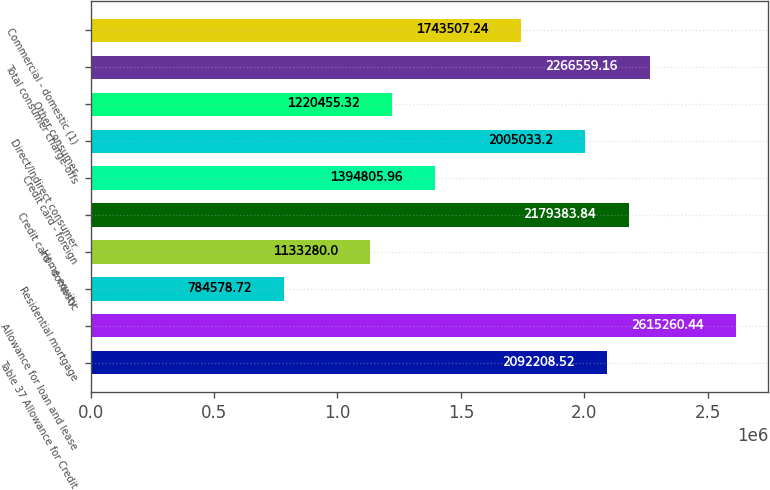Convert chart to OTSL. <chart><loc_0><loc_0><loc_500><loc_500><bar_chart><fcel>Table 37 Allowance for Credit<fcel>Allowance for loan and lease<fcel>Residential mortgage<fcel>Home equity<fcel>Credit card - domestic<fcel>Credit card - foreign<fcel>Direct/Indirect consumer<fcel>Other consumer<fcel>Total consumer charge-offs<fcel>Commercial - domestic (1)<nl><fcel>2.09221e+06<fcel>2.61526e+06<fcel>784579<fcel>1.13328e+06<fcel>2.17938e+06<fcel>1.39481e+06<fcel>2.00503e+06<fcel>1.22046e+06<fcel>2.26656e+06<fcel>1.74351e+06<nl></chart> 